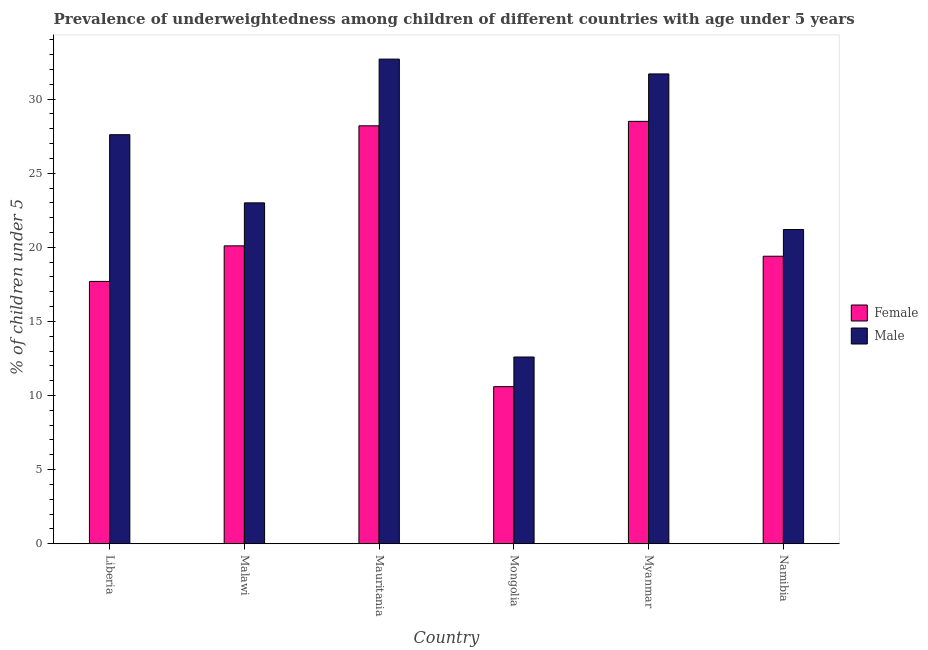How many different coloured bars are there?
Ensure brevity in your answer.  2. How many groups of bars are there?
Provide a short and direct response. 6. Are the number of bars per tick equal to the number of legend labels?
Make the answer very short. Yes. Are the number of bars on each tick of the X-axis equal?
Your response must be concise. Yes. How many bars are there on the 2nd tick from the right?
Provide a short and direct response. 2. What is the label of the 6th group of bars from the left?
Keep it short and to the point. Namibia. What is the percentage of underweighted male children in Mauritania?
Your response must be concise. 32.7. Across all countries, what is the maximum percentage of underweighted female children?
Offer a very short reply. 28.5. Across all countries, what is the minimum percentage of underweighted male children?
Offer a very short reply. 12.6. In which country was the percentage of underweighted female children maximum?
Provide a short and direct response. Myanmar. In which country was the percentage of underweighted male children minimum?
Your answer should be very brief. Mongolia. What is the total percentage of underweighted female children in the graph?
Your answer should be compact. 124.5. What is the difference between the percentage of underweighted male children in Liberia and that in Myanmar?
Keep it short and to the point. -4.1. What is the difference between the percentage of underweighted female children in Namibia and the percentage of underweighted male children in Myanmar?
Provide a short and direct response. -12.3. What is the average percentage of underweighted female children per country?
Make the answer very short. 20.75. What is the difference between the percentage of underweighted male children and percentage of underweighted female children in Mongolia?
Your response must be concise. 2. In how many countries, is the percentage of underweighted female children greater than 10 %?
Provide a succinct answer. 6. What is the ratio of the percentage of underweighted male children in Myanmar to that in Namibia?
Offer a very short reply. 1.5. What is the difference between the highest and the second highest percentage of underweighted female children?
Give a very brief answer. 0.3. What is the difference between the highest and the lowest percentage of underweighted female children?
Offer a very short reply. 17.9. In how many countries, is the percentage of underweighted male children greater than the average percentage of underweighted male children taken over all countries?
Offer a very short reply. 3. What does the 1st bar from the left in Malawi represents?
Offer a very short reply. Female. Are all the bars in the graph horizontal?
Your answer should be compact. No. How many countries are there in the graph?
Your answer should be very brief. 6. What is the difference between two consecutive major ticks on the Y-axis?
Give a very brief answer. 5. Does the graph contain grids?
Provide a short and direct response. No. Where does the legend appear in the graph?
Your answer should be compact. Center right. How many legend labels are there?
Your answer should be compact. 2. How are the legend labels stacked?
Offer a terse response. Vertical. What is the title of the graph?
Keep it short and to the point. Prevalence of underweightedness among children of different countries with age under 5 years. Does "Nonresident" appear as one of the legend labels in the graph?
Offer a very short reply. No. What is the label or title of the Y-axis?
Provide a short and direct response.  % of children under 5. What is the  % of children under 5 in Female in Liberia?
Offer a very short reply. 17.7. What is the  % of children under 5 of Male in Liberia?
Your answer should be compact. 27.6. What is the  % of children under 5 in Female in Malawi?
Make the answer very short. 20.1. What is the  % of children under 5 of Female in Mauritania?
Provide a succinct answer. 28.2. What is the  % of children under 5 of Male in Mauritania?
Give a very brief answer. 32.7. What is the  % of children under 5 of Female in Mongolia?
Give a very brief answer. 10.6. What is the  % of children under 5 in Male in Mongolia?
Give a very brief answer. 12.6. What is the  % of children under 5 in Female in Myanmar?
Offer a very short reply. 28.5. What is the  % of children under 5 of Male in Myanmar?
Offer a very short reply. 31.7. What is the  % of children under 5 in Female in Namibia?
Provide a short and direct response. 19.4. What is the  % of children under 5 in Male in Namibia?
Your response must be concise. 21.2. Across all countries, what is the maximum  % of children under 5 of Female?
Your answer should be very brief. 28.5. Across all countries, what is the maximum  % of children under 5 in Male?
Give a very brief answer. 32.7. Across all countries, what is the minimum  % of children under 5 in Female?
Give a very brief answer. 10.6. Across all countries, what is the minimum  % of children under 5 in Male?
Make the answer very short. 12.6. What is the total  % of children under 5 of Female in the graph?
Give a very brief answer. 124.5. What is the total  % of children under 5 in Male in the graph?
Provide a short and direct response. 148.8. What is the difference between the  % of children under 5 in Female in Liberia and that in Myanmar?
Provide a short and direct response. -10.8. What is the difference between the  % of children under 5 in Female in Liberia and that in Namibia?
Give a very brief answer. -1.7. What is the difference between the  % of children under 5 of Female in Malawi and that in Mauritania?
Provide a short and direct response. -8.1. What is the difference between the  % of children under 5 of Male in Malawi and that in Mauritania?
Give a very brief answer. -9.7. What is the difference between the  % of children under 5 of Female in Malawi and that in Myanmar?
Make the answer very short. -8.4. What is the difference between the  % of children under 5 in Female in Malawi and that in Namibia?
Offer a terse response. 0.7. What is the difference between the  % of children under 5 in Female in Mauritania and that in Mongolia?
Give a very brief answer. 17.6. What is the difference between the  % of children under 5 of Male in Mauritania and that in Mongolia?
Offer a very short reply. 20.1. What is the difference between the  % of children under 5 in Female in Mauritania and that in Myanmar?
Offer a terse response. -0.3. What is the difference between the  % of children under 5 in Male in Mauritania and that in Myanmar?
Your answer should be compact. 1. What is the difference between the  % of children under 5 in Male in Mauritania and that in Namibia?
Give a very brief answer. 11.5. What is the difference between the  % of children under 5 in Female in Mongolia and that in Myanmar?
Your answer should be compact. -17.9. What is the difference between the  % of children under 5 in Male in Mongolia and that in Myanmar?
Offer a very short reply. -19.1. What is the difference between the  % of children under 5 in Female in Mongolia and that in Namibia?
Your answer should be very brief. -8.8. What is the difference between the  % of children under 5 of Male in Mongolia and that in Namibia?
Keep it short and to the point. -8.6. What is the difference between the  % of children under 5 in Female in Liberia and the  % of children under 5 in Male in Malawi?
Offer a very short reply. -5.3. What is the difference between the  % of children under 5 of Female in Liberia and the  % of children under 5 of Male in Mauritania?
Your answer should be compact. -15. What is the difference between the  % of children under 5 of Female in Liberia and the  % of children under 5 of Male in Namibia?
Make the answer very short. -3.5. What is the difference between the  % of children under 5 of Female in Malawi and the  % of children under 5 of Male in Mongolia?
Offer a terse response. 7.5. What is the difference between the  % of children under 5 of Female in Mauritania and the  % of children under 5 of Male in Namibia?
Ensure brevity in your answer.  7. What is the difference between the  % of children under 5 of Female in Mongolia and the  % of children under 5 of Male in Myanmar?
Make the answer very short. -21.1. What is the difference between the  % of children under 5 of Female in Mongolia and the  % of children under 5 of Male in Namibia?
Give a very brief answer. -10.6. What is the difference between the  % of children under 5 in Female in Myanmar and the  % of children under 5 in Male in Namibia?
Provide a succinct answer. 7.3. What is the average  % of children under 5 of Female per country?
Offer a terse response. 20.75. What is the average  % of children under 5 in Male per country?
Ensure brevity in your answer.  24.8. What is the difference between the  % of children under 5 of Female and  % of children under 5 of Male in Malawi?
Offer a terse response. -2.9. What is the difference between the  % of children under 5 of Female and  % of children under 5 of Male in Mauritania?
Make the answer very short. -4.5. What is the difference between the  % of children under 5 of Female and  % of children under 5 of Male in Myanmar?
Your answer should be very brief. -3.2. What is the difference between the  % of children under 5 in Female and  % of children under 5 in Male in Namibia?
Provide a succinct answer. -1.8. What is the ratio of the  % of children under 5 of Female in Liberia to that in Malawi?
Your answer should be very brief. 0.88. What is the ratio of the  % of children under 5 in Female in Liberia to that in Mauritania?
Your response must be concise. 0.63. What is the ratio of the  % of children under 5 of Male in Liberia to that in Mauritania?
Make the answer very short. 0.84. What is the ratio of the  % of children under 5 in Female in Liberia to that in Mongolia?
Provide a short and direct response. 1.67. What is the ratio of the  % of children under 5 of Male in Liberia to that in Mongolia?
Provide a succinct answer. 2.19. What is the ratio of the  % of children under 5 in Female in Liberia to that in Myanmar?
Provide a short and direct response. 0.62. What is the ratio of the  % of children under 5 in Male in Liberia to that in Myanmar?
Your response must be concise. 0.87. What is the ratio of the  % of children under 5 of Female in Liberia to that in Namibia?
Offer a terse response. 0.91. What is the ratio of the  % of children under 5 of Male in Liberia to that in Namibia?
Offer a very short reply. 1.3. What is the ratio of the  % of children under 5 of Female in Malawi to that in Mauritania?
Provide a short and direct response. 0.71. What is the ratio of the  % of children under 5 of Male in Malawi to that in Mauritania?
Ensure brevity in your answer.  0.7. What is the ratio of the  % of children under 5 in Female in Malawi to that in Mongolia?
Keep it short and to the point. 1.9. What is the ratio of the  % of children under 5 of Male in Malawi to that in Mongolia?
Keep it short and to the point. 1.83. What is the ratio of the  % of children under 5 in Female in Malawi to that in Myanmar?
Offer a very short reply. 0.71. What is the ratio of the  % of children under 5 of Male in Malawi to that in Myanmar?
Give a very brief answer. 0.73. What is the ratio of the  % of children under 5 in Female in Malawi to that in Namibia?
Keep it short and to the point. 1.04. What is the ratio of the  % of children under 5 of Male in Malawi to that in Namibia?
Provide a short and direct response. 1.08. What is the ratio of the  % of children under 5 in Female in Mauritania to that in Mongolia?
Give a very brief answer. 2.66. What is the ratio of the  % of children under 5 of Male in Mauritania to that in Mongolia?
Offer a very short reply. 2.6. What is the ratio of the  % of children under 5 of Female in Mauritania to that in Myanmar?
Your response must be concise. 0.99. What is the ratio of the  % of children under 5 in Male in Mauritania to that in Myanmar?
Offer a very short reply. 1.03. What is the ratio of the  % of children under 5 of Female in Mauritania to that in Namibia?
Your answer should be compact. 1.45. What is the ratio of the  % of children under 5 of Male in Mauritania to that in Namibia?
Give a very brief answer. 1.54. What is the ratio of the  % of children under 5 in Female in Mongolia to that in Myanmar?
Give a very brief answer. 0.37. What is the ratio of the  % of children under 5 in Male in Mongolia to that in Myanmar?
Ensure brevity in your answer.  0.4. What is the ratio of the  % of children under 5 in Female in Mongolia to that in Namibia?
Offer a terse response. 0.55. What is the ratio of the  % of children under 5 of Male in Mongolia to that in Namibia?
Make the answer very short. 0.59. What is the ratio of the  % of children under 5 in Female in Myanmar to that in Namibia?
Your answer should be very brief. 1.47. What is the ratio of the  % of children under 5 of Male in Myanmar to that in Namibia?
Make the answer very short. 1.5. What is the difference between the highest and the lowest  % of children under 5 in Female?
Your answer should be very brief. 17.9. What is the difference between the highest and the lowest  % of children under 5 of Male?
Keep it short and to the point. 20.1. 